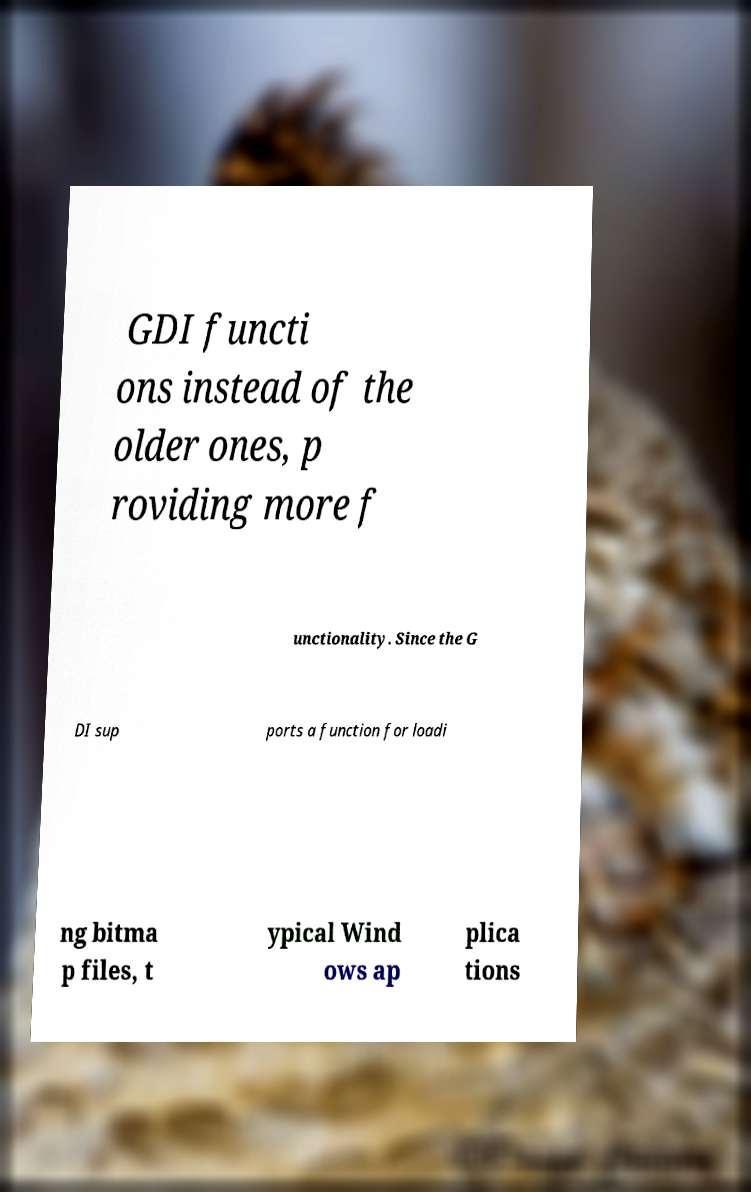Can you accurately transcribe the text from the provided image for me? GDI functi ons instead of the older ones, p roviding more f unctionality. Since the G DI sup ports a function for loadi ng bitma p files, t ypical Wind ows ap plica tions 